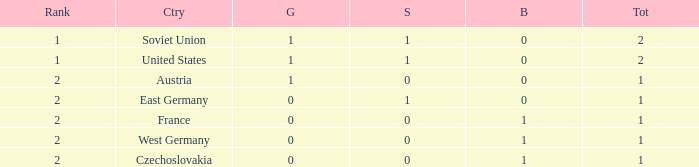What is the rank of the team with 0 gold and less than 0 silvers? None. Parse the table in full. {'header': ['Rank', 'Ctry', 'G', 'S', 'B', 'Tot'], 'rows': [['1', 'Soviet Union', '1', '1', '0', '2'], ['1', 'United States', '1', '1', '0', '2'], ['2', 'Austria', '1', '0', '0', '1'], ['2', 'East Germany', '0', '1', '0', '1'], ['2', 'France', '0', '0', '1', '1'], ['2', 'West Germany', '0', '0', '1', '1'], ['2', 'Czechoslovakia', '0', '0', '1', '1']]} 